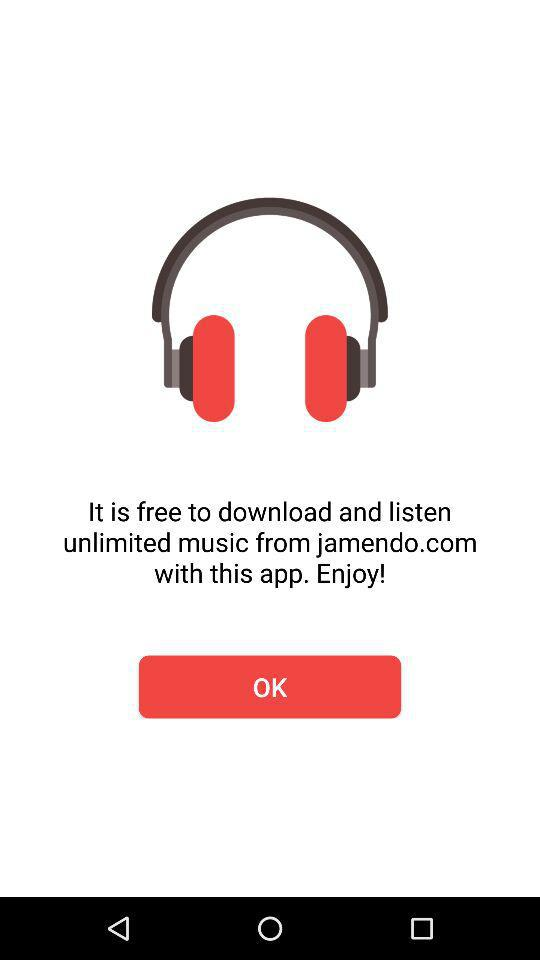What is the name of the application through which we can listen to unlimited music? The name of the application is "jamendo". 